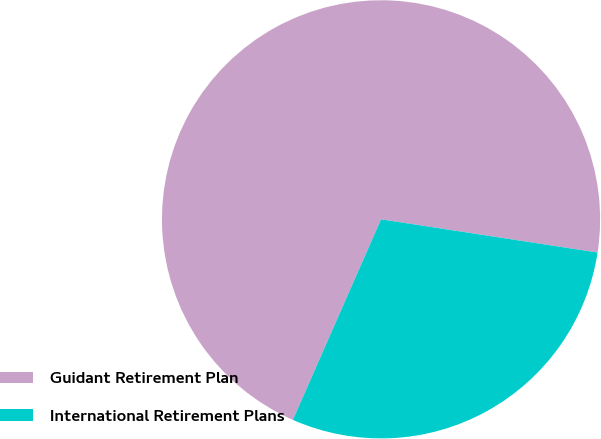Convert chart. <chart><loc_0><loc_0><loc_500><loc_500><pie_chart><fcel>Guidant Retirement Plan<fcel>International Retirement Plans<nl><fcel>70.83%<fcel>29.17%<nl></chart> 